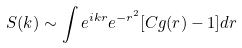Convert formula to latex. <formula><loc_0><loc_0><loc_500><loc_500>S ( { k } ) \sim \int e ^ { i { k } { r } } e ^ { - r ^ { 2 } } [ C g ( r ) - 1 ] d { r }</formula> 